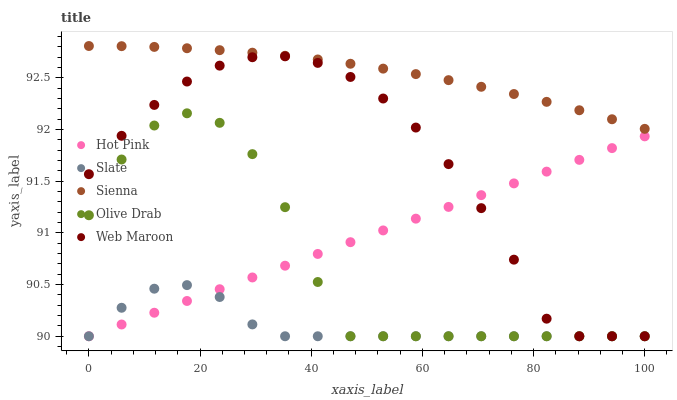Does Slate have the minimum area under the curve?
Answer yes or no. Yes. Does Sienna have the maximum area under the curve?
Answer yes or no. Yes. Does Hot Pink have the minimum area under the curve?
Answer yes or no. No. Does Hot Pink have the maximum area under the curve?
Answer yes or no. No. Is Hot Pink the smoothest?
Answer yes or no. Yes. Is Olive Drab the roughest?
Answer yes or no. Yes. Is Slate the smoothest?
Answer yes or no. No. Is Slate the roughest?
Answer yes or no. No. Does Slate have the lowest value?
Answer yes or no. Yes. Does Sienna have the highest value?
Answer yes or no. Yes. Does Hot Pink have the highest value?
Answer yes or no. No. Is Slate less than Sienna?
Answer yes or no. Yes. Is Sienna greater than Hot Pink?
Answer yes or no. Yes. Does Olive Drab intersect Slate?
Answer yes or no. Yes. Is Olive Drab less than Slate?
Answer yes or no. No. Is Olive Drab greater than Slate?
Answer yes or no. No. Does Slate intersect Sienna?
Answer yes or no. No. 